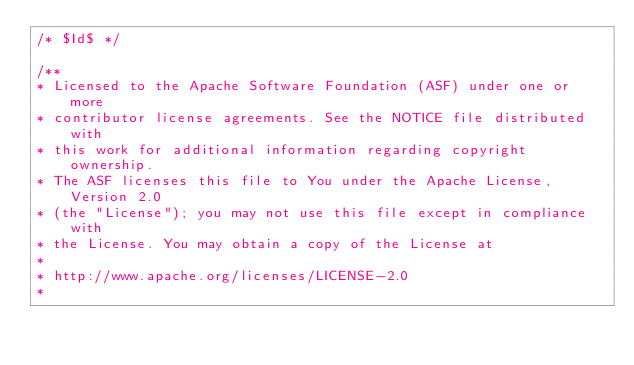<code> <loc_0><loc_0><loc_500><loc_500><_Java_>/* $Id$ */

/**
* Licensed to the Apache Software Foundation (ASF) under one or more
* contributor license agreements. See the NOTICE file distributed with
* this work for additional information regarding copyright ownership.
* The ASF licenses this file to You under the Apache License, Version 2.0
* (the "License"); you may not use this file except in compliance with
* the License. You may obtain a copy of the License at
*
* http://www.apache.org/licenses/LICENSE-2.0
*</code> 